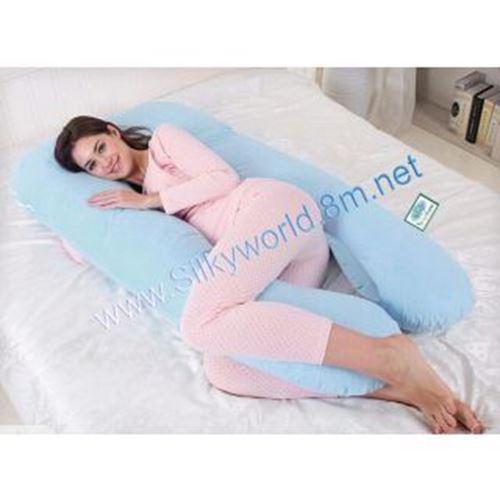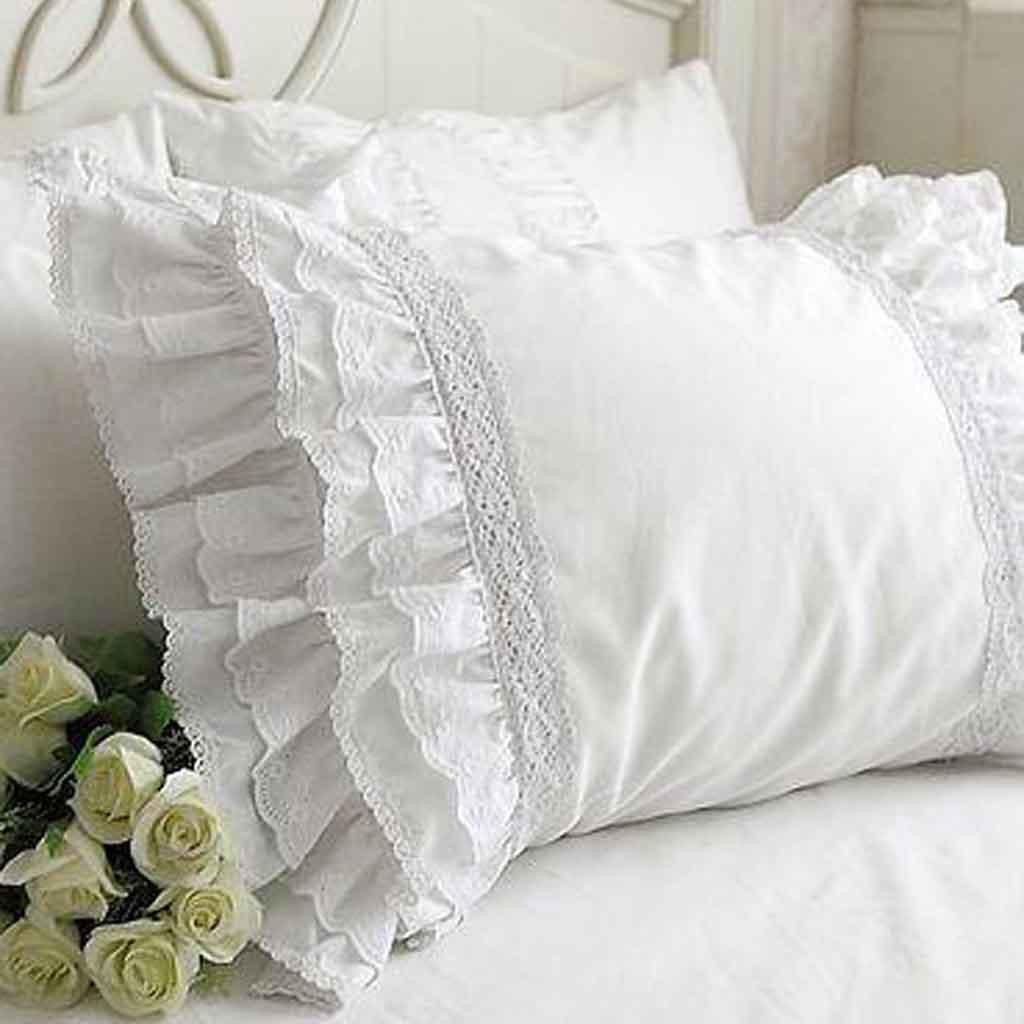The first image is the image on the left, the second image is the image on the right. For the images shown, is this caption "There is something pink on a bed." true? Answer yes or no. Yes. 